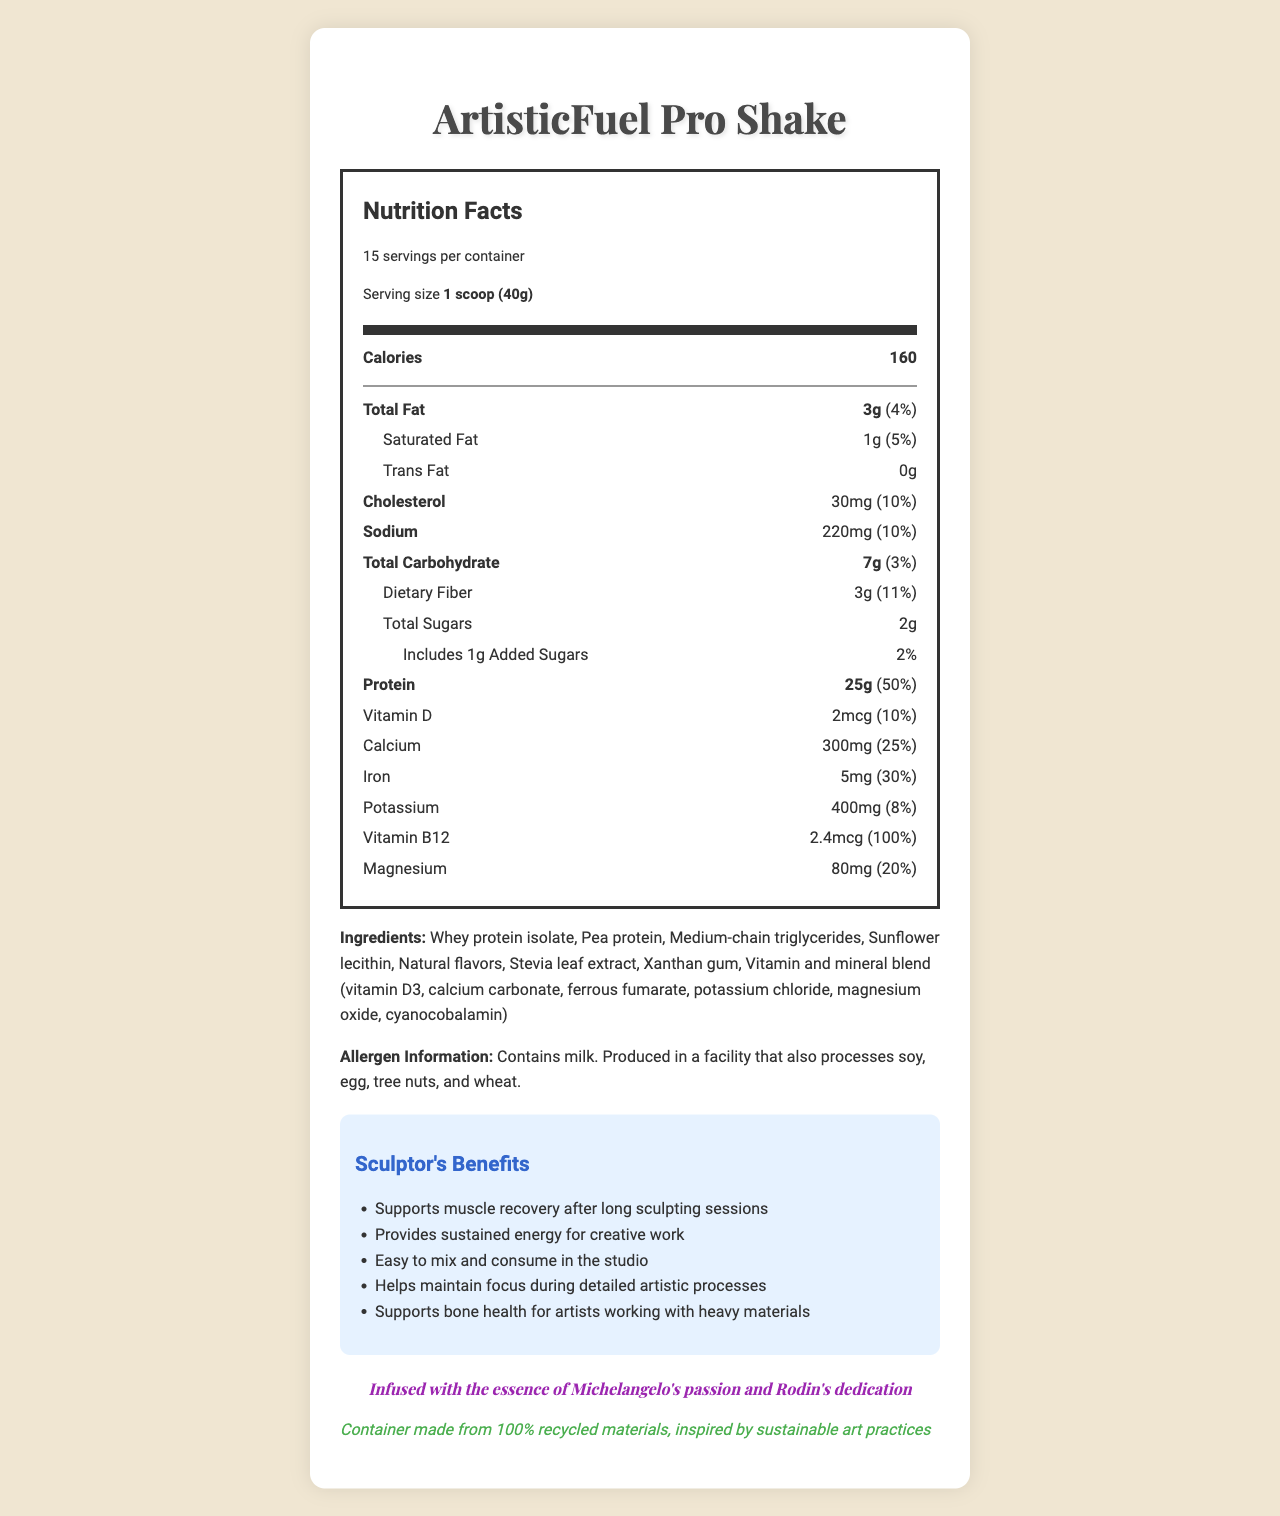what is the serving size of ArtisticFuel Pro Shake? The serving size is stated in the serving information section under the product name.
Answer: 1 scoop (40g) how many servings are in one container of ArtisticFuel Pro Shake? The document mentions that there are 15 servings per container.
Answer: 15 how many calories are in each serving? The number of calories per serving is listed under the Nutrition Facts.
Answer: 160 what is the total amount of fat in one serving? The total fat content per serving is indicated under the nutrient breakdown.
Answer: 3g how much protein does one serving contain? The amount of protein per serving is highlighted in the nutrient breakdown.
Answer: 25g what is the percentage daily value of Vitamin B12 in one serving? A. 10% B. 25% C. 50% D. 100% The daily value percentage for Vitamin B12 is listed as 100%.
Answer: D which of the following is an ingredient in the ArtisticFuel Pro Shake? A. Sucralose B. Stevia leaf extract C. Soy Protein D. Fructose Stevia leaf extract is listed as one of the ingredients in the ingredient section.
Answer: B does the ArtisticFuel Pro Shake contain any added sugars? The document shows that each serving includes 1g of added sugars.
Answer: Yes are there any allergens in the ArtisticFuel Pro Shake? The allergen information specifies that it contains milk and is produced in a facility that also processes soy, egg, tree nuts, and wheat.
Answer: Yes summarize the sculptor-specific benefits of the ArtisticFuel Pro Shake. The sculptor-specific benefits section lists several unique advantages tailored for artists, emphasizing muscle recovery, energy, ease of use, focus, and bone health.
Answer: The ArtisticFuel Pro Shake supports muscle recovery, provides sustained energy, is easy to consume in the studio, helps maintain focus during detailed processes, and supports bone health. is the product packaging eco-friendly? The document indicates that the container is made from 100% recycled materials, inspired by sustainable art practices.
Answer: Yes how much fiber is in each serving, and what is its daily value percentage? The dietary fiber per serving is listed as 3g with an 11% daily value percentage.
Answer: 3g, 11% what inspired the ArtisticFuel Pro Shake? The artistic inspiration section specifies the influence behind the product.
Answer: Michelangelo's passion and Rodin's dedication can the amount of biotin in each serving be found in the document? The document does not provide information about the amount of biotin.
Answer: Cannot be determined 